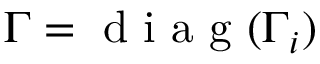<formula> <loc_0><loc_0><loc_500><loc_500>\Gamma = d i a g ( \Gamma _ { i } )</formula> 